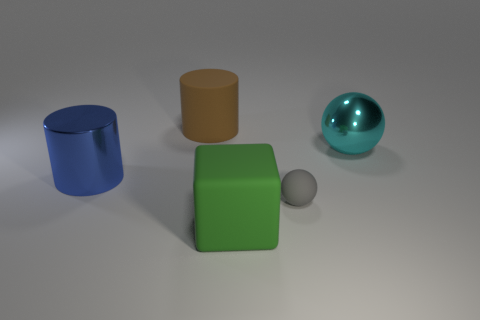There is a blue shiny object; does it have the same size as the matte thing on the left side of the big cube?
Provide a succinct answer. Yes. How many objects are either large cyan spheres or small green metal things?
Ensure brevity in your answer.  1. How many other objects are the same size as the gray object?
Provide a short and direct response. 0. What number of balls are green matte objects or tiny rubber things?
Ensure brevity in your answer.  1. There is a big cylinder to the left of the object behind the large cyan ball; what is it made of?
Make the answer very short. Metal. Do the cube and the large cylinder in front of the cyan metal object have the same material?
Your response must be concise. No. What number of things are metal objects that are on the right side of the large green thing or large gray metal cylinders?
Your answer should be compact. 1. Does the green matte object have the same shape as the big rubber thing that is behind the large cyan shiny thing?
Make the answer very short. No. How many large things are right of the large rubber cylinder and left of the large cyan thing?
Offer a terse response. 1. There is a small gray thing that is the same shape as the big cyan thing; what is its material?
Keep it short and to the point. Rubber. 